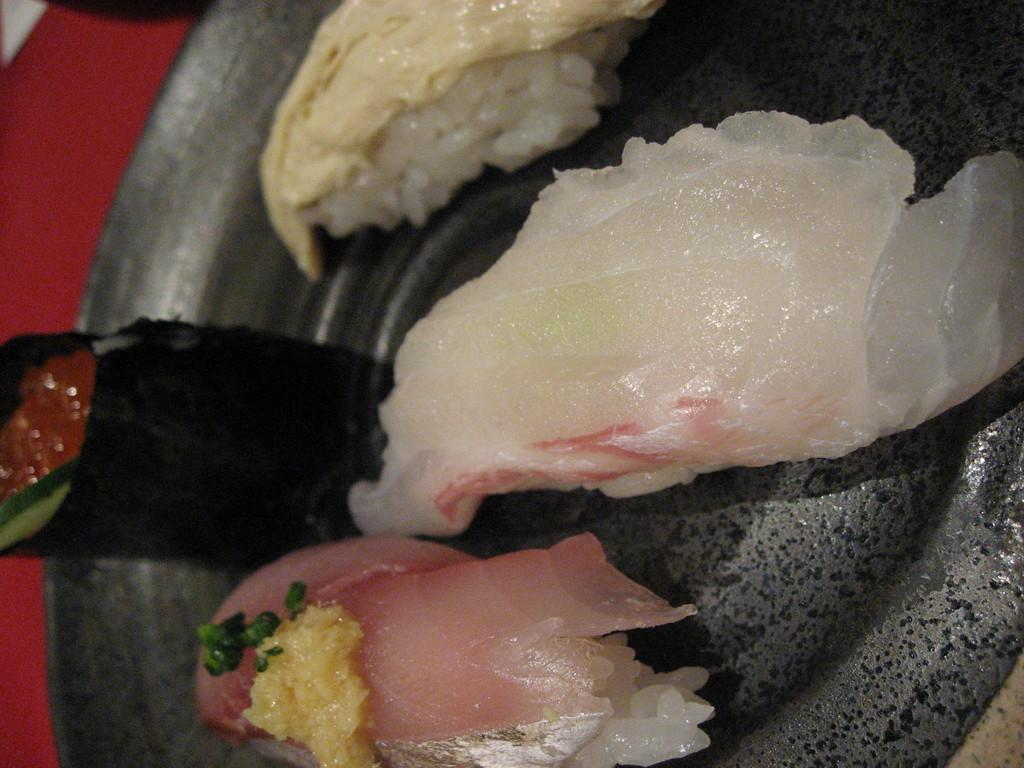What is located in the foreground of the image? There is a platter in the foreground of the image. What is on the platter? The platter contains seafood. What can be seen in the background of the image? There is a red-colored table in the background of the image. How many books are stacked on the red-colored table in the image? There are no books visible in the image; it only shows a platter with seafood in the foreground and a red-colored table in the background. 